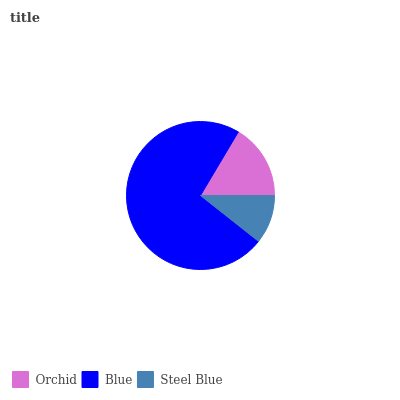Is Steel Blue the minimum?
Answer yes or no. Yes. Is Blue the maximum?
Answer yes or no. Yes. Is Blue the minimum?
Answer yes or no. No. Is Steel Blue the maximum?
Answer yes or no. No. Is Blue greater than Steel Blue?
Answer yes or no. Yes. Is Steel Blue less than Blue?
Answer yes or no. Yes. Is Steel Blue greater than Blue?
Answer yes or no. No. Is Blue less than Steel Blue?
Answer yes or no. No. Is Orchid the high median?
Answer yes or no. Yes. Is Orchid the low median?
Answer yes or no. Yes. Is Blue the high median?
Answer yes or no. No. Is Steel Blue the low median?
Answer yes or no. No. 